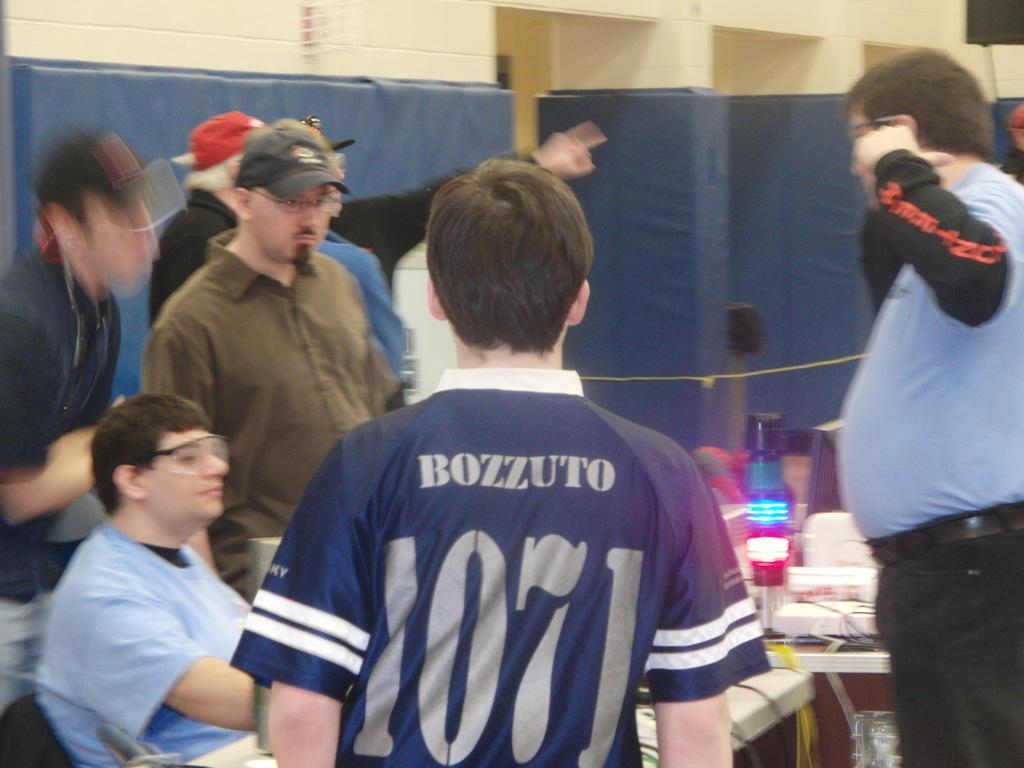<image>
Present a compact description of the photo's key features. Young man in a blue shirt standing in front of several adults back towards camera with Bozzuto 1071 written on shirt. 